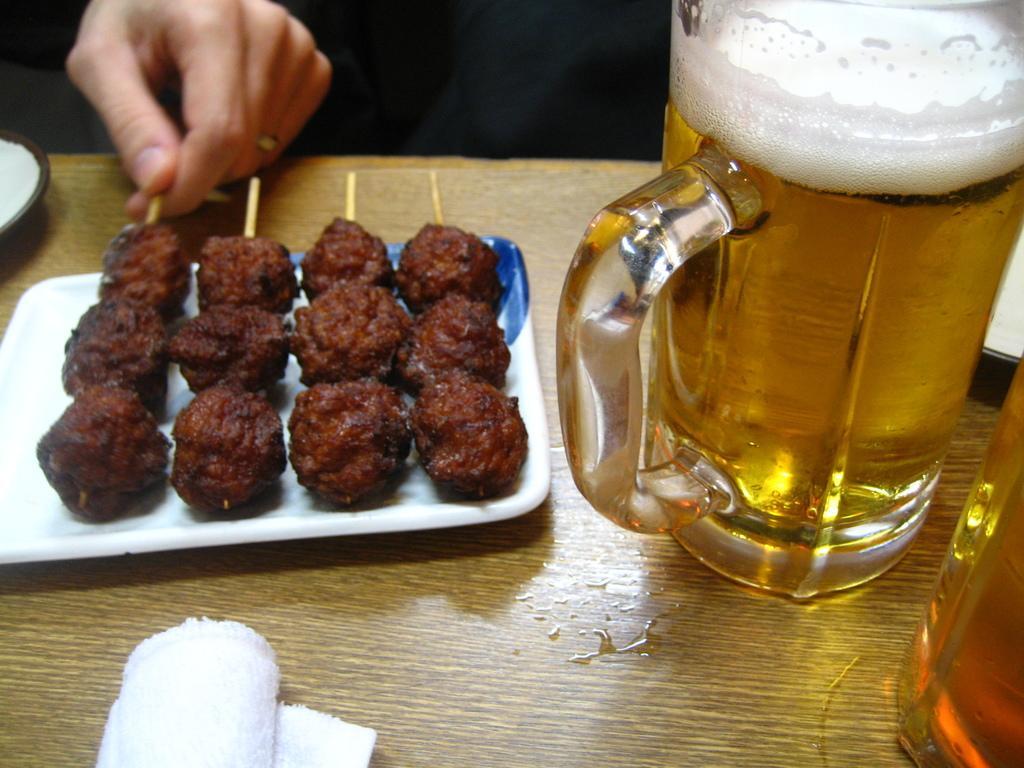Can you describe this image briefly? In this picture, we see a plate containing food item, tissue roll, jar containing beer and plates are placed on the table. At the top, we see the hand of the person. At the top, it is black in color. 